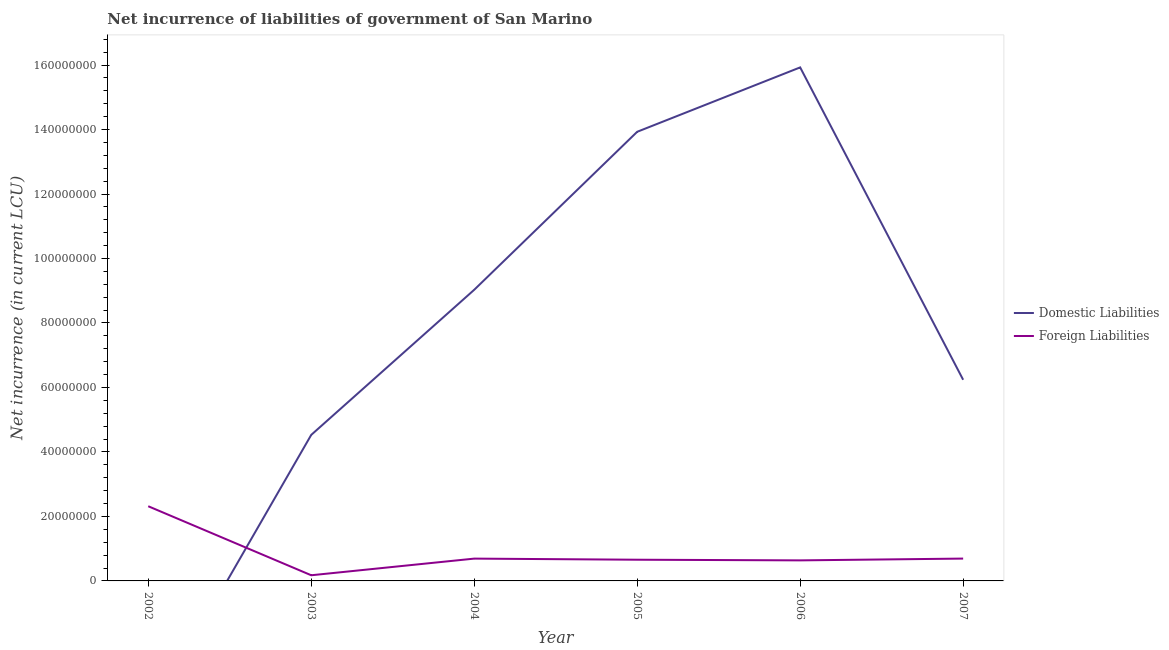How many different coloured lines are there?
Your answer should be compact. 2. Is the number of lines equal to the number of legend labels?
Make the answer very short. No. What is the net incurrence of foreign liabilities in 2005?
Provide a succinct answer. 6.57e+06. Across all years, what is the maximum net incurrence of foreign liabilities?
Give a very brief answer. 2.32e+07. What is the total net incurrence of domestic liabilities in the graph?
Provide a succinct answer. 4.97e+08. What is the difference between the net incurrence of foreign liabilities in 2003 and that in 2006?
Provide a succinct answer. -4.62e+06. What is the difference between the net incurrence of domestic liabilities in 2006 and the net incurrence of foreign liabilities in 2003?
Provide a succinct answer. 1.58e+08. What is the average net incurrence of domestic liabilities per year?
Keep it short and to the point. 8.28e+07. In the year 2006, what is the difference between the net incurrence of foreign liabilities and net incurrence of domestic liabilities?
Ensure brevity in your answer.  -1.53e+08. What is the ratio of the net incurrence of foreign liabilities in 2004 to that in 2006?
Offer a terse response. 1.09. What is the difference between the highest and the second highest net incurrence of foreign liabilities?
Your answer should be very brief. 1.62e+07. What is the difference between the highest and the lowest net incurrence of domestic liabilities?
Keep it short and to the point. 1.59e+08. In how many years, is the net incurrence of foreign liabilities greater than the average net incurrence of foreign liabilities taken over all years?
Provide a succinct answer. 1. Is the sum of the net incurrence of foreign liabilities in 2003 and 2007 greater than the maximum net incurrence of domestic liabilities across all years?
Offer a terse response. No. Does the net incurrence of foreign liabilities monotonically increase over the years?
Your answer should be very brief. No. Is the net incurrence of domestic liabilities strictly greater than the net incurrence of foreign liabilities over the years?
Offer a terse response. No. How many lines are there?
Keep it short and to the point. 2. How many years are there in the graph?
Provide a succinct answer. 6. What is the difference between two consecutive major ticks on the Y-axis?
Provide a succinct answer. 2.00e+07. Are the values on the major ticks of Y-axis written in scientific E-notation?
Keep it short and to the point. No. Does the graph contain any zero values?
Provide a short and direct response. Yes. Does the graph contain grids?
Make the answer very short. No. How are the legend labels stacked?
Ensure brevity in your answer.  Vertical. What is the title of the graph?
Provide a succinct answer. Net incurrence of liabilities of government of San Marino. What is the label or title of the X-axis?
Offer a terse response. Year. What is the label or title of the Y-axis?
Your answer should be compact. Net incurrence (in current LCU). What is the Net incurrence (in current LCU) of Foreign Liabilities in 2002?
Your answer should be compact. 2.32e+07. What is the Net incurrence (in current LCU) in Domestic Liabilities in 2003?
Give a very brief answer. 4.53e+07. What is the Net incurrence (in current LCU) of Foreign Liabilities in 2003?
Your answer should be compact. 1.76e+06. What is the Net incurrence (in current LCU) in Domestic Liabilities in 2004?
Give a very brief answer. 9.03e+07. What is the Net incurrence (in current LCU) in Foreign Liabilities in 2004?
Your response must be concise. 6.92e+06. What is the Net incurrence (in current LCU) of Domestic Liabilities in 2005?
Give a very brief answer. 1.39e+08. What is the Net incurrence (in current LCU) of Foreign Liabilities in 2005?
Ensure brevity in your answer.  6.57e+06. What is the Net incurrence (in current LCU) in Domestic Liabilities in 2006?
Your answer should be very brief. 1.59e+08. What is the Net incurrence (in current LCU) in Foreign Liabilities in 2006?
Your answer should be very brief. 6.37e+06. What is the Net incurrence (in current LCU) in Domestic Liabilities in 2007?
Provide a short and direct response. 6.24e+07. What is the Net incurrence (in current LCU) in Foreign Liabilities in 2007?
Your response must be concise. 6.93e+06. Across all years, what is the maximum Net incurrence (in current LCU) in Domestic Liabilities?
Provide a succinct answer. 1.59e+08. Across all years, what is the maximum Net incurrence (in current LCU) in Foreign Liabilities?
Provide a short and direct response. 2.32e+07. Across all years, what is the minimum Net incurrence (in current LCU) of Domestic Liabilities?
Offer a terse response. 0. Across all years, what is the minimum Net incurrence (in current LCU) in Foreign Liabilities?
Offer a terse response. 1.76e+06. What is the total Net incurrence (in current LCU) of Domestic Liabilities in the graph?
Your response must be concise. 4.97e+08. What is the total Net incurrence (in current LCU) in Foreign Liabilities in the graph?
Ensure brevity in your answer.  5.17e+07. What is the difference between the Net incurrence (in current LCU) in Foreign Liabilities in 2002 and that in 2003?
Make the answer very short. 2.14e+07. What is the difference between the Net incurrence (in current LCU) of Foreign Liabilities in 2002 and that in 2004?
Offer a very short reply. 1.62e+07. What is the difference between the Net incurrence (in current LCU) in Foreign Liabilities in 2002 and that in 2005?
Your response must be concise. 1.66e+07. What is the difference between the Net incurrence (in current LCU) in Foreign Liabilities in 2002 and that in 2006?
Keep it short and to the point. 1.68e+07. What is the difference between the Net incurrence (in current LCU) in Foreign Liabilities in 2002 and that in 2007?
Provide a succinct answer. 1.62e+07. What is the difference between the Net incurrence (in current LCU) in Domestic Liabilities in 2003 and that in 2004?
Ensure brevity in your answer.  -4.50e+07. What is the difference between the Net incurrence (in current LCU) in Foreign Liabilities in 2003 and that in 2004?
Offer a terse response. -5.16e+06. What is the difference between the Net incurrence (in current LCU) in Domestic Liabilities in 2003 and that in 2005?
Your answer should be compact. -9.40e+07. What is the difference between the Net incurrence (in current LCU) in Foreign Liabilities in 2003 and that in 2005?
Your answer should be very brief. -4.82e+06. What is the difference between the Net incurrence (in current LCU) in Domestic Liabilities in 2003 and that in 2006?
Ensure brevity in your answer.  -1.14e+08. What is the difference between the Net incurrence (in current LCU) of Foreign Liabilities in 2003 and that in 2006?
Offer a very short reply. -4.62e+06. What is the difference between the Net incurrence (in current LCU) in Domestic Liabilities in 2003 and that in 2007?
Your answer should be compact. -1.71e+07. What is the difference between the Net incurrence (in current LCU) of Foreign Liabilities in 2003 and that in 2007?
Offer a very short reply. -5.17e+06. What is the difference between the Net incurrence (in current LCU) of Domestic Liabilities in 2004 and that in 2005?
Give a very brief answer. -4.90e+07. What is the difference between the Net incurrence (in current LCU) in Foreign Liabilities in 2004 and that in 2005?
Make the answer very short. 3.44e+05. What is the difference between the Net incurrence (in current LCU) in Domestic Liabilities in 2004 and that in 2006?
Give a very brief answer. -6.90e+07. What is the difference between the Net incurrence (in current LCU) in Foreign Liabilities in 2004 and that in 2006?
Offer a terse response. 5.46e+05. What is the difference between the Net incurrence (in current LCU) of Domestic Liabilities in 2004 and that in 2007?
Offer a very short reply. 2.79e+07. What is the difference between the Net incurrence (in current LCU) of Foreign Liabilities in 2004 and that in 2007?
Give a very brief answer. -1.10e+04. What is the difference between the Net incurrence (in current LCU) in Domestic Liabilities in 2005 and that in 2006?
Your answer should be compact. -2.00e+07. What is the difference between the Net incurrence (in current LCU) of Foreign Liabilities in 2005 and that in 2006?
Offer a very short reply. 2.02e+05. What is the difference between the Net incurrence (in current LCU) in Domestic Liabilities in 2005 and that in 2007?
Your answer should be compact. 7.69e+07. What is the difference between the Net incurrence (in current LCU) in Foreign Liabilities in 2005 and that in 2007?
Your response must be concise. -3.55e+05. What is the difference between the Net incurrence (in current LCU) in Domestic Liabilities in 2006 and that in 2007?
Your answer should be compact. 9.69e+07. What is the difference between the Net incurrence (in current LCU) in Foreign Liabilities in 2006 and that in 2007?
Provide a short and direct response. -5.57e+05. What is the difference between the Net incurrence (in current LCU) in Domestic Liabilities in 2003 and the Net incurrence (in current LCU) in Foreign Liabilities in 2004?
Your response must be concise. 3.84e+07. What is the difference between the Net incurrence (in current LCU) of Domestic Liabilities in 2003 and the Net incurrence (in current LCU) of Foreign Liabilities in 2005?
Give a very brief answer. 3.87e+07. What is the difference between the Net incurrence (in current LCU) of Domestic Liabilities in 2003 and the Net incurrence (in current LCU) of Foreign Liabilities in 2006?
Offer a very short reply. 3.89e+07. What is the difference between the Net incurrence (in current LCU) of Domestic Liabilities in 2003 and the Net incurrence (in current LCU) of Foreign Liabilities in 2007?
Give a very brief answer. 3.84e+07. What is the difference between the Net incurrence (in current LCU) in Domestic Liabilities in 2004 and the Net incurrence (in current LCU) in Foreign Liabilities in 2005?
Provide a short and direct response. 8.37e+07. What is the difference between the Net incurrence (in current LCU) of Domestic Liabilities in 2004 and the Net incurrence (in current LCU) of Foreign Liabilities in 2006?
Ensure brevity in your answer.  8.39e+07. What is the difference between the Net incurrence (in current LCU) in Domestic Liabilities in 2004 and the Net incurrence (in current LCU) in Foreign Liabilities in 2007?
Ensure brevity in your answer.  8.34e+07. What is the difference between the Net incurrence (in current LCU) of Domestic Liabilities in 2005 and the Net incurrence (in current LCU) of Foreign Liabilities in 2006?
Keep it short and to the point. 1.33e+08. What is the difference between the Net incurrence (in current LCU) of Domestic Liabilities in 2005 and the Net incurrence (in current LCU) of Foreign Liabilities in 2007?
Your response must be concise. 1.32e+08. What is the difference between the Net incurrence (in current LCU) of Domestic Liabilities in 2006 and the Net incurrence (in current LCU) of Foreign Liabilities in 2007?
Provide a succinct answer. 1.52e+08. What is the average Net incurrence (in current LCU) in Domestic Liabilities per year?
Offer a terse response. 8.28e+07. What is the average Net incurrence (in current LCU) of Foreign Liabilities per year?
Make the answer very short. 8.62e+06. In the year 2003, what is the difference between the Net incurrence (in current LCU) of Domestic Liabilities and Net incurrence (in current LCU) of Foreign Liabilities?
Offer a terse response. 4.35e+07. In the year 2004, what is the difference between the Net incurrence (in current LCU) of Domestic Liabilities and Net incurrence (in current LCU) of Foreign Liabilities?
Ensure brevity in your answer.  8.34e+07. In the year 2005, what is the difference between the Net incurrence (in current LCU) in Domestic Liabilities and Net incurrence (in current LCU) in Foreign Liabilities?
Give a very brief answer. 1.33e+08. In the year 2006, what is the difference between the Net incurrence (in current LCU) of Domestic Liabilities and Net incurrence (in current LCU) of Foreign Liabilities?
Your response must be concise. 1.53e+08. In the year 2007, what is the difference between the Net incurrence (in current LCU) in Domestic Liabilities and Net incurrence (in current LCU) in Foreign Liabilities?
Offer a very short reply. 5.55e+07. What is the ratio of the Net incurrence (in current LCU) in Foreign Liabilities in 2002 to that in 2003?
Offer a terse response. 13.18. What is the ratio of the Net incurrence (in current LCU) of Foreign Liabilities in 2002 to that in 2004?
Keep it short and to the point. 3.35. What is the ratio of the Net incurrence (in current LCU) of Foreign Liabilities in 2002 to that in 2005?
Offer a very short reply. 3.52. What is the ratio of the Net incurrence (in current LCU) of Foreign Liabilities in 2002 to that in 2006?
Offer a terse response. 3.63. What is the ratio of the Net incurrence (in current LCU) in Foreign Liabilities in 2002 to that in 2007?
Your answer should be very brief. 3.34. What is the ratio of the Net incurrence (in current LCU) of Domestic Liabilities in 2003 to that in 2004?
Give a very brief answer. 0.5. What is the ratio of the Net incurrence (in current LCU) of Foreign Liabilities in 2003 to that in 2004?
Make the answer very short. 0.25. What is the ratio of the Net incurrence (in current LCU) of Domestic Liabilities in 2003 to that in 2005?
Give a very brief answer. 0.33. What is the ratio of the Net incurrence (in current LCU) of Foreign Liabilities in 2003 to that in 2005?
Provide a short and direct response. 0.27. What is the ratio of the Net incurrence (in current LCU) of Domestic Liabilities in 2003 to that in 2006?
Your response must be concise. 0.28. What is the ratio of the Net incurrence (in current LCU) in Foreign Liabilities in 2003 to that in 2006?
Provide a short and direct response. 0.28. What is the ratio of the Net incurrence (in current LCU) in Domestic Liabilities in 2003 to that in 2007?
Ensure brevity in your answer.  0.73. What is the ratio of the Net incurrence (in current LCU) of Foreign Liabilities in 2003 to that in 2007?
Make the answer very short. 0.25. What is the ratio of the Net incurrence (in current LCU) of Domestic Liabilities in 2004 to that in 2005?
Offer a terse response. 0.65. What is the ratio of the Net incurrence (in current LCU) in Foreign Liabilities in 2004 to that in 2005?
Offer a very short reply. 1.05. What is the ratio of the Net incurrence (in current LCU) in Domestic Liabilities in 2004 to that in 2006?
Keep it short and to the point. 0.57. What is the ratio of the Net incurrence (in current LCU) in Foreign Liabilities in 2004 to that in 2006?
Ensure brevity in your answer.  1.09. What is the ratio of the Net incurrence (in current LCU) of Domestic Liabilities in 2004 to that in 2007?
Keep it short and to the point. 1.45. What is the ratio of the Net incurrence (in current LCU) of Domestic Liabilities in 2005 to that in 2006?
Ensure brevity in your answer.  0.87. What is the ratio of the Net incurrence (in current LCU) in Foreign Liabilities in 2005 to that in 2006?
Your response must be concise. 1.03. What is the ratio of the Net incurrence (in current LCU) in Domestic Liabilities in 2005 to that in 2007?
Make the answer very short. 2.23. What is the ratio of the Net incurrence (in current LCU) of Foreign Liabilities in 2005 to that in 2007?
Keep it short and to the point. 0.95. What is the ratio of the Net incurrence (in current LCU) in Domestic Liabilities in 2006 to that in 2007?
Ensure brevity in your answer.  2.55. What is the ratio of the Net incurrence (in current LCU) of Foreign Liabilities in 2006 to that in 2007?
Give a very brief answer. 0.92. What is the difference between the highest and the second highest Net incurrence (in current LCU) in Domestic Liabilities?
Provide a short and direct response. 2.00e+07. What is the difference between the highest and the second highest Net incurrence (in current LCU) in Foreign Liabilities?
Provide a succinct answer. 1.62e+07. What is the difference between the highest and the lowest Net incurrence (in current LCU) in Domestic Liabilities?
Your response must be concise. 1.59e+08. What is the difference between the highest and the lowest Net incurrence (in current LCU) in Foreign Liabilities?
Offer a terse response. 2.14e+07. 